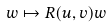Convert formula to latex. <formula><loc_0><loc_0><loc_500><loc_500>w \mapsto R ( u , v ) w</formula> 